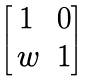<formula> <loc_0><loc_0><loc_500><loc_500>\begin{bmatrix} 1 & 0 \\ \, w & 1 \end{bmatrix}</formula> 